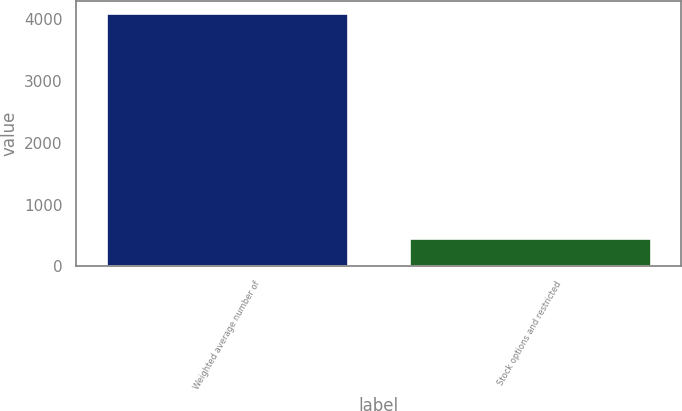<chart> <loc_0><loc_0><loc_500><loc_500><bar_chart><fcel>Weighted average number of<fcel>Stock options and restricted<nl><fcel>4092<fcel>461<nl></chart> 